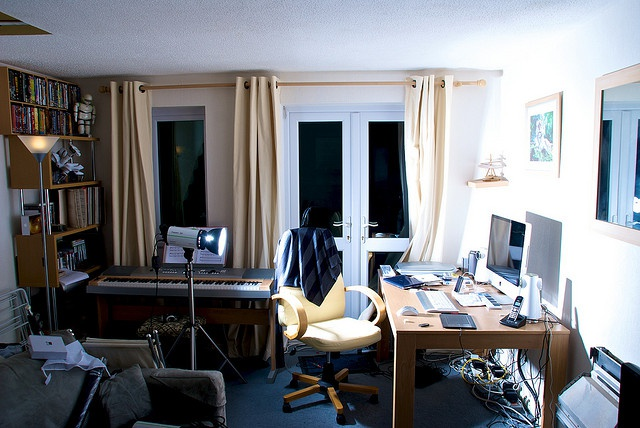Describe the objects in this image and their specific colors. I can see book in gray, black, and maroon tones, couch in gray, black, and blue tones, chair in gray, white, black, and tan tones, chair in gray, black, and blue tones, and tv in gray, darkgray, and black tones in this image. 